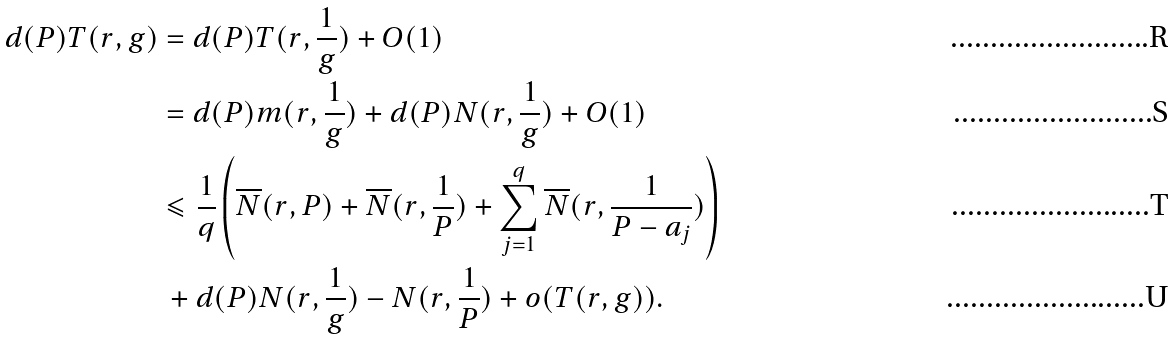<formula> <loc_0><loc_0><loc_500><loc_500>d ( P ) T ( r , g ) & = d ( P ) T ( r , \frac { 1 } { g } ) + O ( 1 ) \\ & = d ( P ) m ( r , \frac { 1 } { g } ) + d ( P ) N ( r , \frac { 1 } { g } ) + O ( 1 ) \\ & \leqslant \frac { 1 } { q } \left ( \overline { N } ( r , P ) + \overline { N } ( r , \frac { 1 } { P } ) + \sum _ { j = 1 } ^ { q } \overline { N } ( r , \frac { 1 } { P - a _ { j } } ) \right ) \\ & \, + d ( P ) N ( r , \frac { 1 } { g } ) - N ( r , \frac { 1 } { P } ) + o ( T ( r , g ) ) .</formula> 